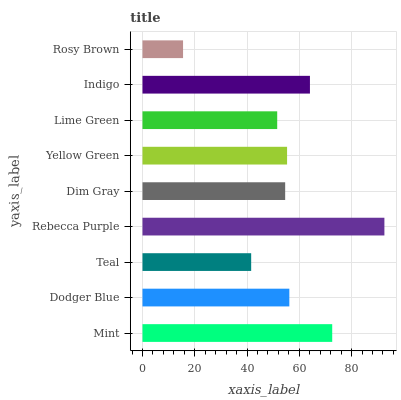Is Rosy Brown the minimum?
Answer yes or no. Yes. Is Rebecca Purple the maximum?
Answer yes or no. Yes. Is Dodger Blue the minimum?
Answer yes or no. No. Is Dodger Blue the maximum?
Answer yes or no. No. Is Mint greater than Dodger Blue?
Answer yes or no. Yes. Is Dodger Blue less than Mint?
Answer yes or no. Yes. Is Dodger Blue greater than Mint?
Answer yes or no. No. Is Mint less than Dodger Blue?
Answer yes or no. No. Is Yellow Green the high median?
Answer yes or no. Yes. Is Yellow Green the low median?
Answer yes or no. Yes. Is Rebecca Purple the high median?
Answer yes or no. No. Is Rosy Brown the low median?
Answer yes or no. No. 